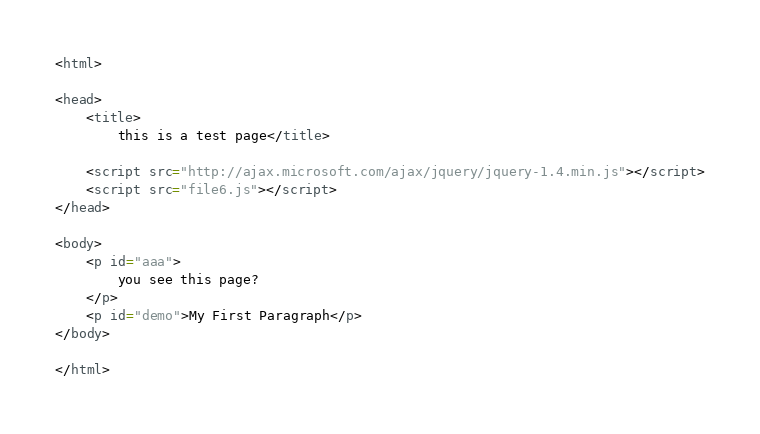<code> <loc_0><loc_0><loc_500><loc_500><_HTML_><html>

<head>
    <title>
        this is a test page</title>

    <script src="http://ajax.microsoft.com/ajax/jquery/jquery-1.4.min.js"></script>
    <script src="file6.js"></script>
</head>

<body>
    <p id="aaa">
        you see this page?
    </p>
    <p id="demo">My First Paragraph</p>
</body>

</html></code> 